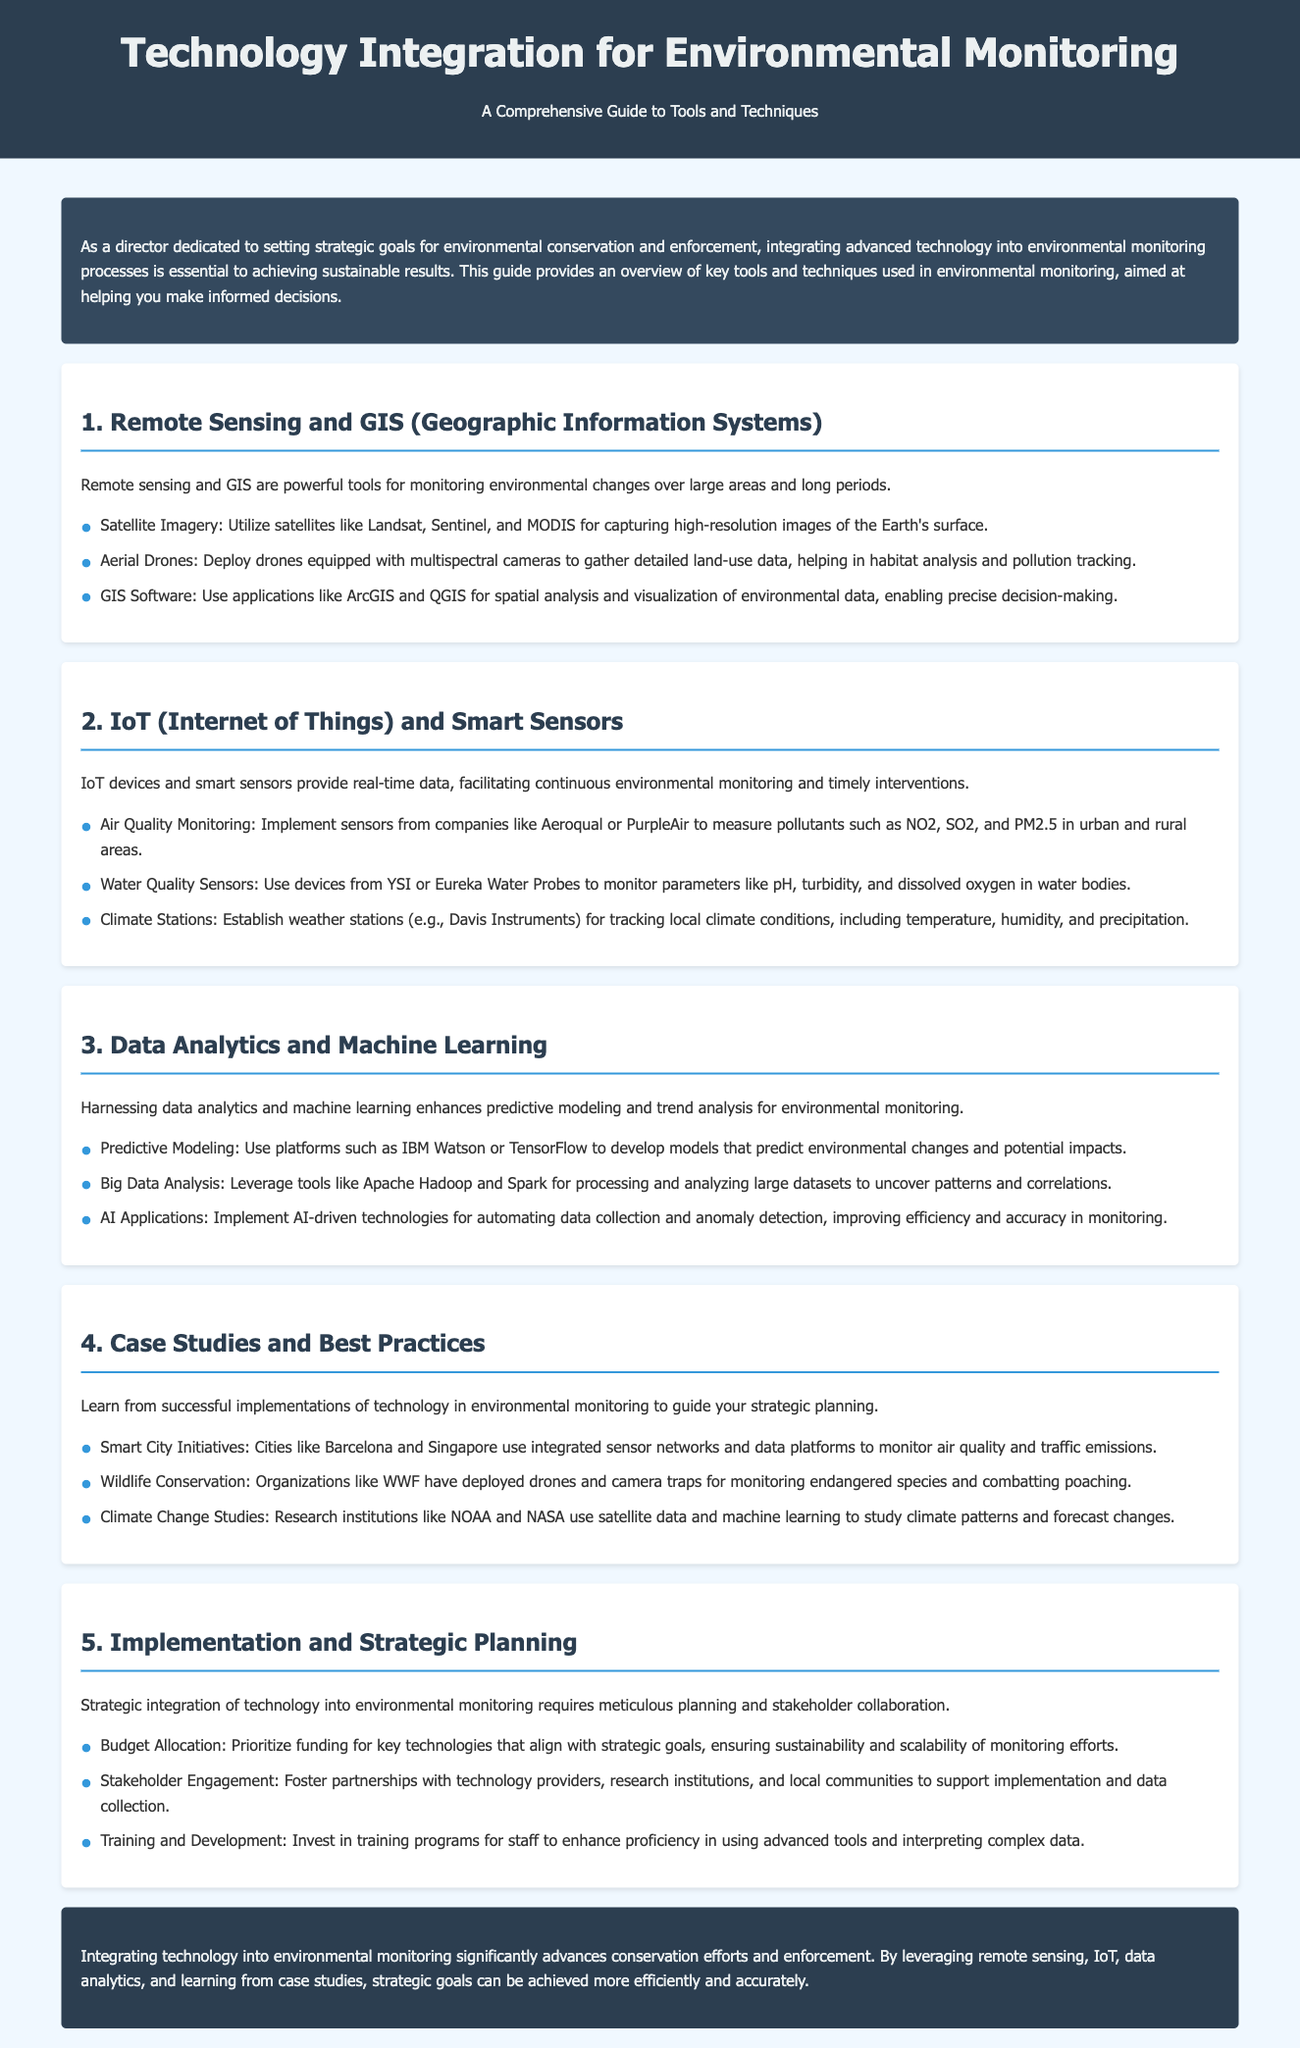what is the title of the document? The title is prominently displayed in the header of the document, which is “Technology Integration for Environmental Monitoring.”
Answer: Technology Integration for Environmental Monitoring how many sections are there in the guide? The guide contains five distinct sections, as numbered in the document.
Answer: 5 name one tool used in Remote Sensing and GIS for environmental monitoring. The document lists tools under the Remote Sensing and GIS section, one of which is satellite imagery.
Answer: Satellite Imagery what is a primary benefit of IoT and Smart Sensors mentioned in the document? The document states that IoT devices and smart sensors provide real-time data, which is a key benefit for continuous monitoring.
Answer: Real-time data which cities are mentioned as examples of Smart City Initiatives? The best practices section of the guide mentions Barcelona and Singapore as examples of cities using integrated sensor networks.
Answer: Barcelona and Singapore what is the purpose of the conclusion in the document? The conclusion summarizes the overall impact of integrating technology into environmental monitoring and reinforces the guide's key messages.
Answer: Summarizes impact what training aspect is highlighted in the Implementation and Strategic Planning section? The document emphasizes the importance of investing in training programs for staff as part of the strategic planning process.
Answer: Training programs name one organization involved in wildlife conservation as mentioned in the guide. The document references the World Wildlife Fund as an organization engaged in wildlife conservation efforts.
Answer: WWF 